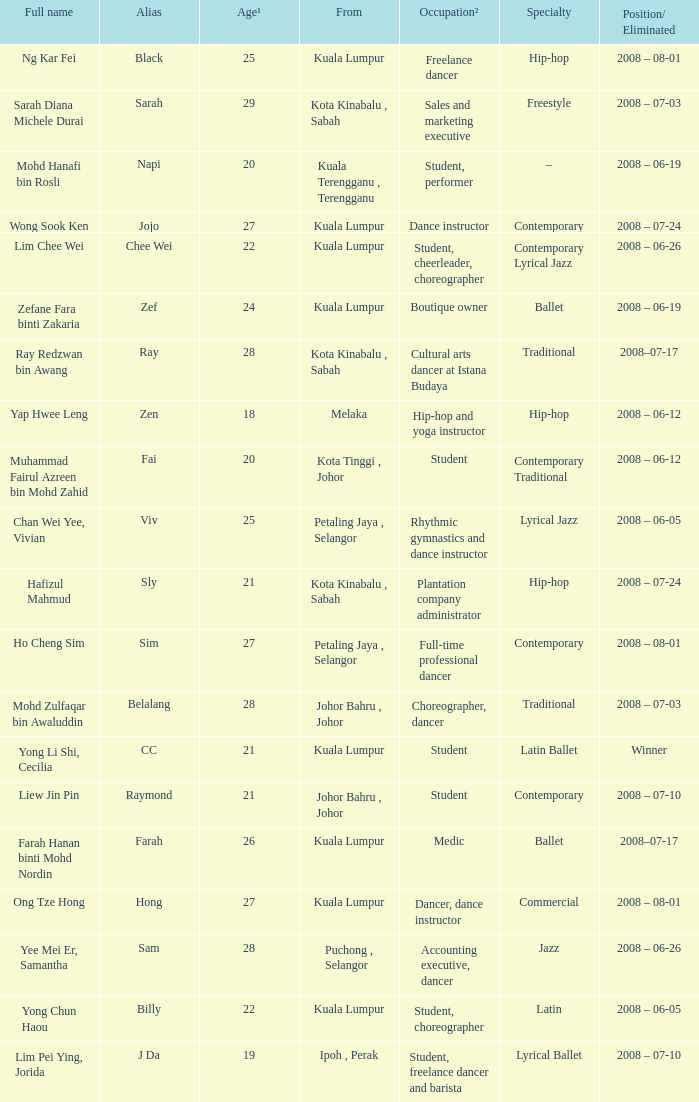What is the occupation² when age¹ exceeds 24 and alias is "black"? Freelance dancer. 